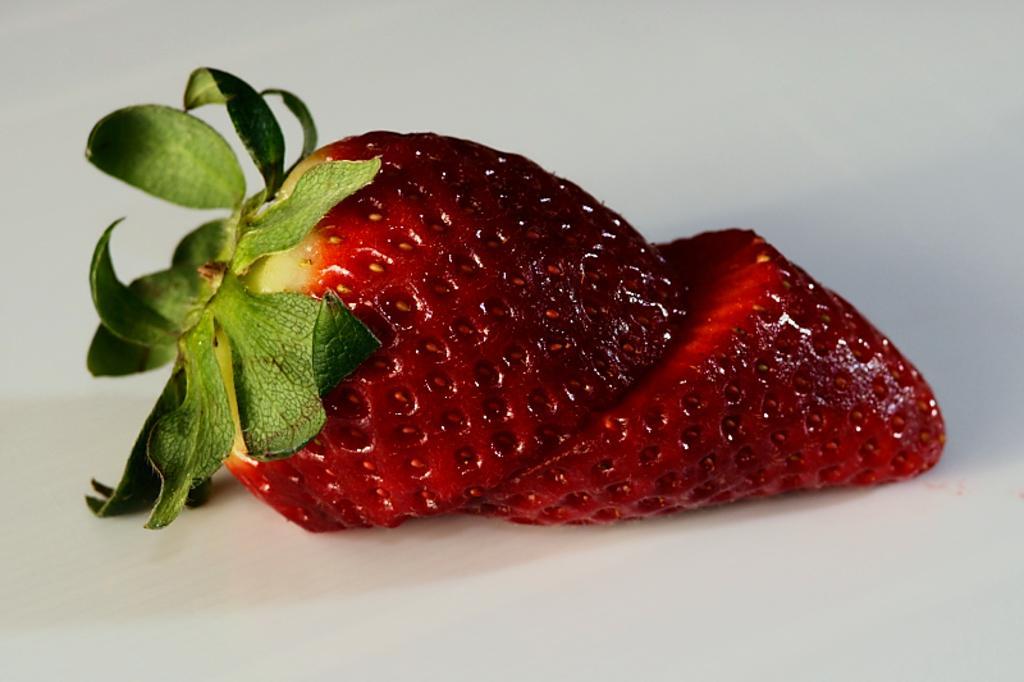How would you summarize this image in a sentence or two? In this image we can see a sliced strawberry. 